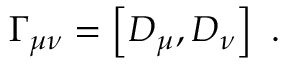Convert formula to latex. <formula><loc_0><loc_0><loc_500><loc_500>\Gamma _ { \mu \nu } = \left [ D _ { \mu } , D _ { \nu } \right ] \ .</formula> 